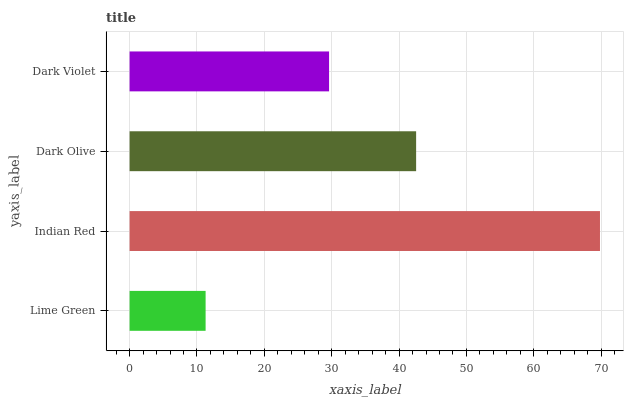Is Lime Green the minimum?
Answer yes or no. Yes. Is Indian Red the maximum?
Answer yes or no. Yes. Is Dark Olive the minimum?
Answer yes or no. No. Is Dark Olive the maximum?
Answer yes or no. No. Is Indian Red greater than Dark Olive?
Answer yes or no. Yes. Is Dark Olive less than Indian Red?
Answer yes or no. Yes. Is Dark Olive greater than Indian Red?
Answer yes or no. No. Is Indian Red less than Dark Olive?
Answer yes or no. No. Is Dark Olive the high median?
Answer yes or no. Yes. Is Dark Violet the low median?
Answer yes or no. Yes. Is Indian Red the high median?
Answer yes or no. No. Is Dark Olive the low median?
Answer yes or no. No. 